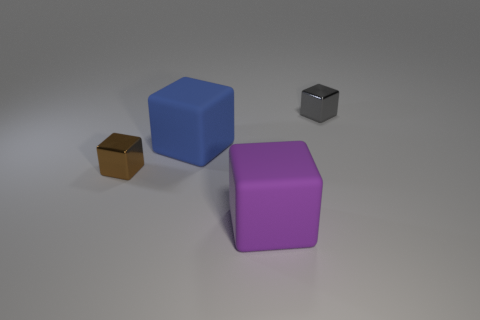Subtract all large purple blocks. How many blocks are left? 3 Subtract all brown blocks. How many blocks are left? 3 Subtract 2 blocks. How many blocks are left? 2 Add 1 small blue shiny things. How many objects exist? 5 Subtract all purple blocks. Subtract all blue spheres. How many blocks are left? 3 Subtract all gray objects. Subtract all gray things. How many objects are left? 2 Add 4 gray metallic blocks. How many gray metallic blocks are left? 5 Add 4 large blue things. How many large blue things exist? 5 Subtract 0 blue balls. How many objects are left? 4 